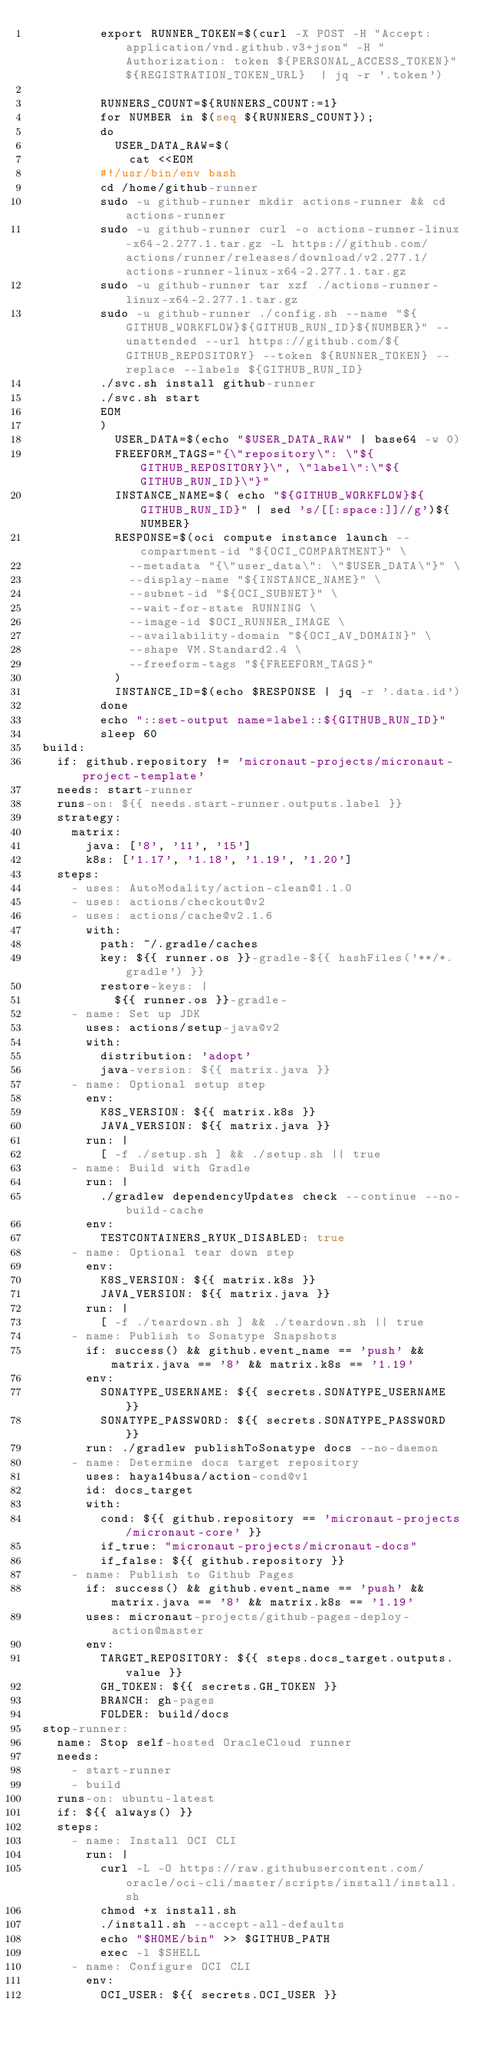<code> <loc_0><loc_0><loc_500><loc_500><_YAML_>          export RUNNER_TOKEN=$(curl -X POST -H "Accept: application/vnd.github.v3+json" -H "Authorization: token ${PERSONAL_ACCESS_TOKEN}" ${REGISTRATION_TOKEN_URL}  | jq -r '.token')

          RUNNERS_COUNT=${RUNNERS_COUNT:=1}
          for NUMBER in $(seq ${RUNNERS_COUNT});
          do
            USER_DATA_RAW=$(
              cat <<EOM
          #!/usr/bin/env bash
          cd /home/github-runner
          sudo -u github-runner mkdir actions-runner && cd actions-runner
          sudo -u github-runner curl -o actions-runner-linux-x64-2.277.1.tar.gz -L https://github.com/actions/runner/releases/download/v2.277.1/actions-runner-linux-x64-2.277.1.tar.gz
          sudo -u github-runner tar xzf ./actions-runner-linux-x64-2.277.1.tar.gz
          sudo -u github-runner ./config.sh --name "${GITHUB_WORKFLOW}${GITHUB_RUN_ID}${NUMBER}" --unattended --url https://github.com/${GITHUB_REPOSITORY} --token ${RUNNER_TOKEN} --replace --labels ${GITHUB_RUN_ID}
          ./svc.sh install github-runner
          ./svc.sh start
          EOM
          )
            USER_DATA=$(echo "$USER_DATA_RAW" | base64 -w 0)
            FREEFORM_TAGS="{\"repository\": \"${GITHUB_REPOSITORY}\", \"label\":\"${GITHUB_RUN_ID}\"}"
            INSTANCE_NAME=$( echo "${GITHUB_WORKFLOW}${GITHUB_RUN_ID}" | sed 's/[[:space:]]//g')${NUMBER}
            RESPONSE=$(oci compute instance launch --compartment-id "${OCI_COMPARTMENT}" \
              --metadata "{\"user_data\": \"$USER_DATA\"}" \
              --display-name "${INSTANCE_NAME}" \
              --subnet-id "${OCI_SUBNET}" \
              --wait-for-state RUNNING \
              --image-id $OCI_RUNNER_IMAGE \
              --availability-domain "${OCI_AV_DOMAIN}" \
              --shape VM.Standard2.4 \
              --freeform-tags "${FREEFORM_TAGS}"
            )
            INSTANCE_ID=$(echo $RESPONSE | jq -r '.data.id')
          done
          echo "::set-output name=label::${GITHUB_RUN_ID}"
          sleep 60
  build:
    if: github.repository != 'micronaut-projects/micronaut-project-template'
    needs: start-runner
    runs-on: ${{ needs.start-runner.outputs.label }}
    strategy:
      matrix:
        java: ['8', '11', '15']
        k8s: ['1.17', '1.18', '1.19', '1.20']
    steps:
      - uses: AutoModality/action-clean@1.1.0
      - uses: actions/checkout@v2
      - uses: actions/cache@v2.1.6
        with:
          path: ~/.gradle/caches
          key: ${{ runner.os }}-gradle-${{ hashFiles('**/*.gradle') }}
          restore-keys: |
            ${{ runner.os }}-gradle-
      - name: Set up JDK
        uses: actions/setup-java@v2
        with:
          distribution: 'adopt'
          java-version: ${{ matrix.java }}
      - name: Optional setup step
        env:
          K8S_VERSION: ${{ matrix.k8s }}
          JAVA_VERSION: ${{ matrix.java }}
        run: |
          [ -f ./setup.sh ] && ./setup.sh || true
      - name: Build with Gradle
        run: |
          ./gradlew dependencyUpdates check --continue --no-build-cache
        env:
          TESTCONTAINERS_RYUK_DISABLED: true
      - name: Optional tear down step
        env:
          K8S_VERSION: ${{ matrix.k8s }}
          JAVA_VERSION: ${{ matrix.java }}
        run: |
          [ -f ./teardown.sh ] && ./teardown.sh || true
      - name: Publish to Sonatype Snapshots
        if: success() && github.event_name == 'push' && matrix.java == '8' && matrix.k8s == '1.19'
        env:
          SONATYPE_USERNAME: ${{ secrets.SONATYPE_USERNAME }}
          SONATYPE_PASSWORD: ${{ secrets.SONATYPE_PASSWORD }}
        run: ./gradlew publishToSonatype docs --no-daemon
      - name: Determine docs target repository
        uses: haya14busa/action-cond@v1
        id: docs_target
        with:
          cond: ${{ github.repository == 'micronaut-projects/micronaut-core' }}
          if_true: "micronaut-projects/micronaut-docs"
          if_false: ${{ github.repository }}
      - name: Publish to Github Pages
        if: success() && github.event_name == 'push' && matrix.java == '8' && matrix.k8s == '1.19'
        uses: micronaut-projects/github-pages-deploy-action@master
        env:
          TARGET_REPOSITORY: ${{ steps.docs_target.outputs.value }}
          GH_TOKEN: ${{ secrets.GH_TOKEN }}
          BRANCH: gh-pages
          FOLDER: build/docs
  stop-runner:
    name: Stop self-hosted OracleCloud runner
    needs:
      - start-runner
      - build
    runs-on: ubuntu-latest
    if: ${{ always() }}
    steps:
      - name: Install OCI CLI
        run: |
          curl -L -O https://raw.githubusercontent.com/oracle/oci-cli/master/scripts/install/install.sh
          chmod +x install.sh
          ./install.sh --accept-all-defaults
          echo "$HOME/bin" >> $GITHUB_PATH
          exec -l $SHELL
      - name: Configure OCI CLI
        env:
          OCI_USER: ${{ secrets.OCI_USER }}</code> 